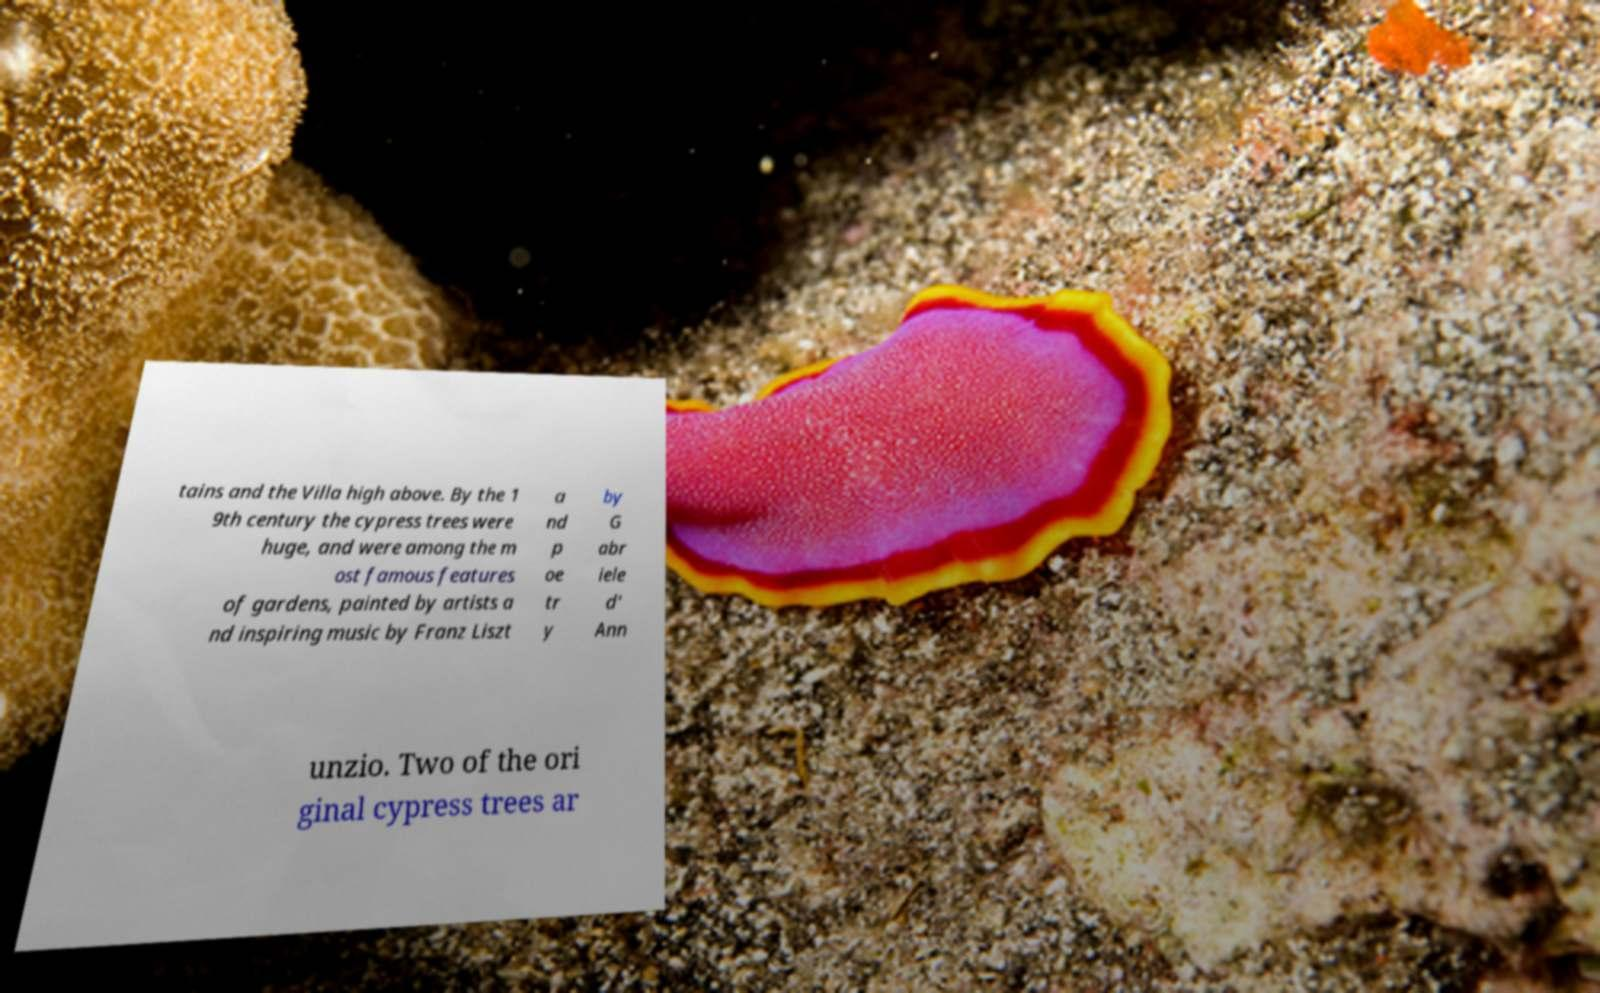Please identify and transcribe the text found in this image. tains and the Villa high above. By the 1 9th century the cypress trees were huge, and were among the m ost famous features of gardens, painted by artists a nd inspiring music by Franz Liszt a nd p oe tr y by G abr iele d' Ann unzio. Two of the ori ginal cypress trees ar 